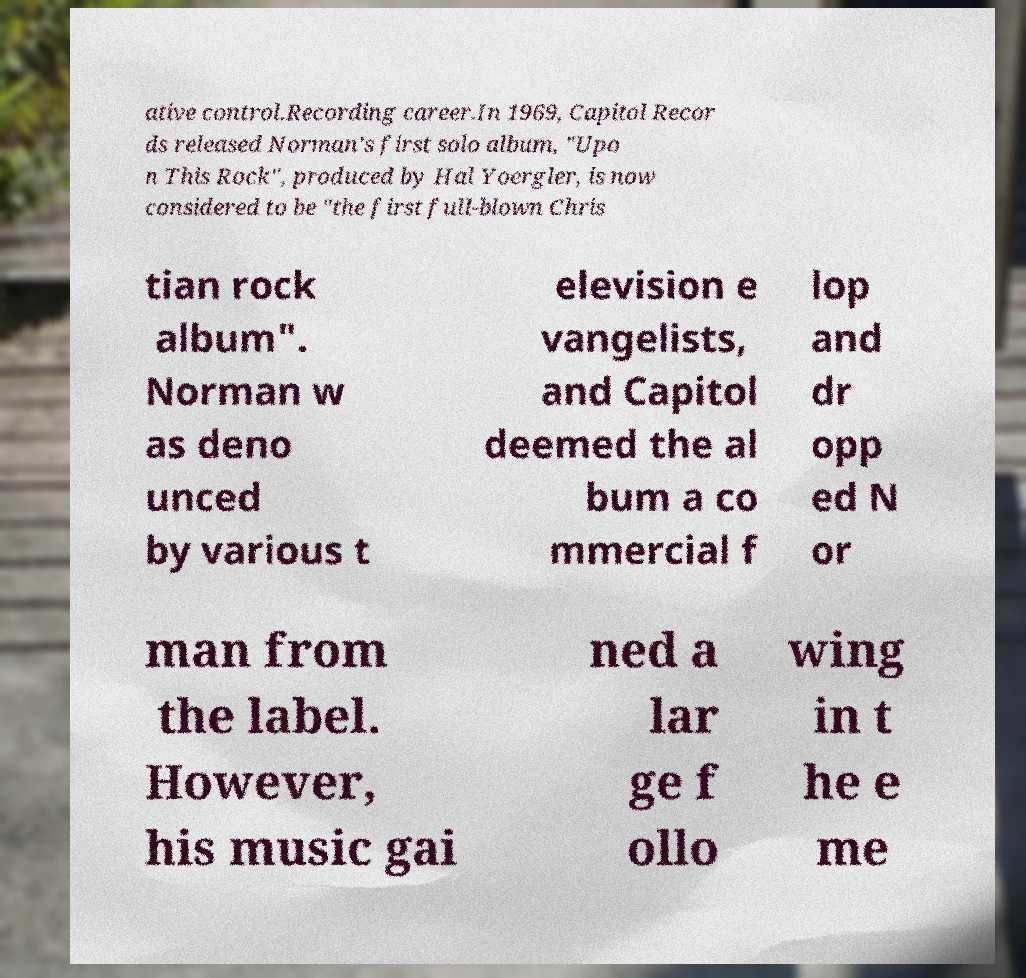What messages or text are displayed in this image? I need them in a readable, typed format. ative control.Recording career.In 1969, Capitol Recor ds released Norman's first solo album, "Upo n This Rock", produced by Hal Yoergler, is now considered to be "the first full-blown Chris tian rock album". Norman w as deno unced by various t elevision e vangelists, and Capitol deemed the al bum a co mmercial f lop and dr opp ed N or man from the label. However, his music gai ned a lar ge f ollo wing in t he e me 